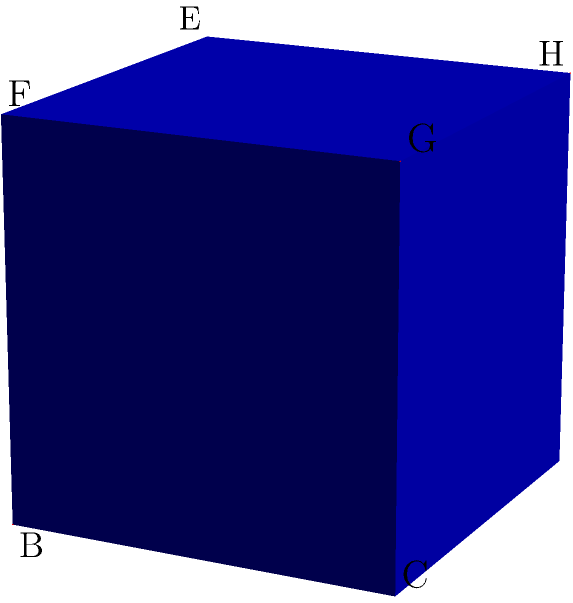In the context of 3D geometric modeling for computer graphics, consider a unit cube ABCDEFGH as shown in the figure. Two planes intersect within this cube: plane BFGC (containing diagonal FG) and plane AEHD (containing diagonal EH). Determine the angle between these two planes. How might this calculation be relevant in optimizing 3D rendering algorithms for EU-funded graphics research projects? To find the angle between two intersecting planes, we can use the following steps:

1) First, we need to find the normal vectors of both planes:
   - For plane BFGC: $\vec{n}_1 = \vec{BF} \times \vec{BC} = (0,1,1) \times (0,1,0) = (1,0,0)$
   - For plane AEHD: $\vec{n}_2 = \vec{AE} \times \vec{AD} = (0,0,1) \times (0,1,0) = (1,0,0)$

2) The angle between the planes is the same as the angle between their normal vectors. We can find this using the dot product formula:

   $$\cos \theta = \frac{\vec{n}_1 \cdot \vec{n}_2}{|\vec{n}_1||\vec{n}_2|}$$

3) Calculating:
   $$\cos \theta = \frac{(1,0,0) \cdot (1,0,0)}{|(1,0,0)||(1,0,0)|} = \frac{1}{1} = 1$$

4) Therefore, $\theta = \arccos(1) = 0°$

This calculation is relevant in optimizing 3D rendering algorithms as it helps in determining the orientation of surfaces in 3D space. In EU-funded graphics research projects, such calculations could be crucial for improving the efficiency of ray tracing algorithms, enhancing real-time rendering techniques, or developing more accurate collision detection methods in virtual environments.
Answer: $0°$ 